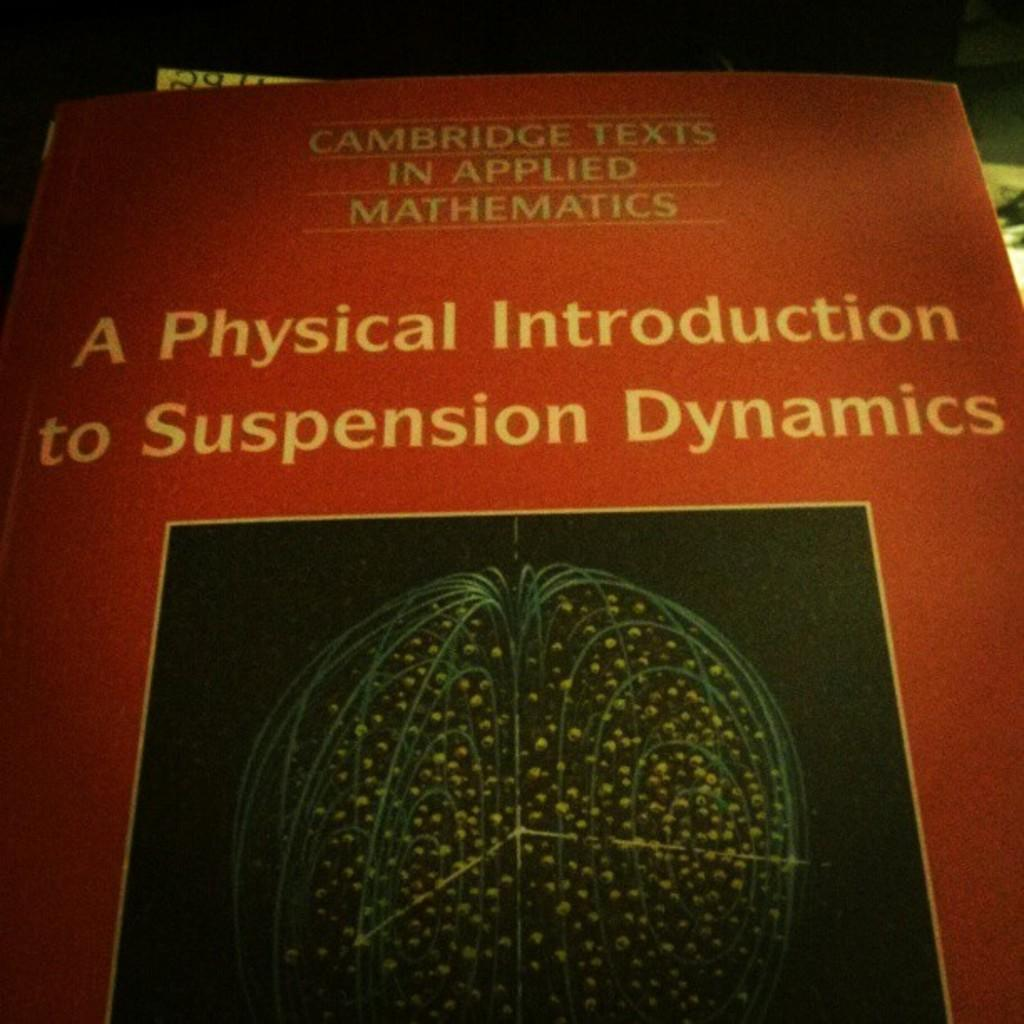Provide a one-sentence caption for the provided image. The front page of a book titled, A Physical Introduction to Suspension Dynamics. 